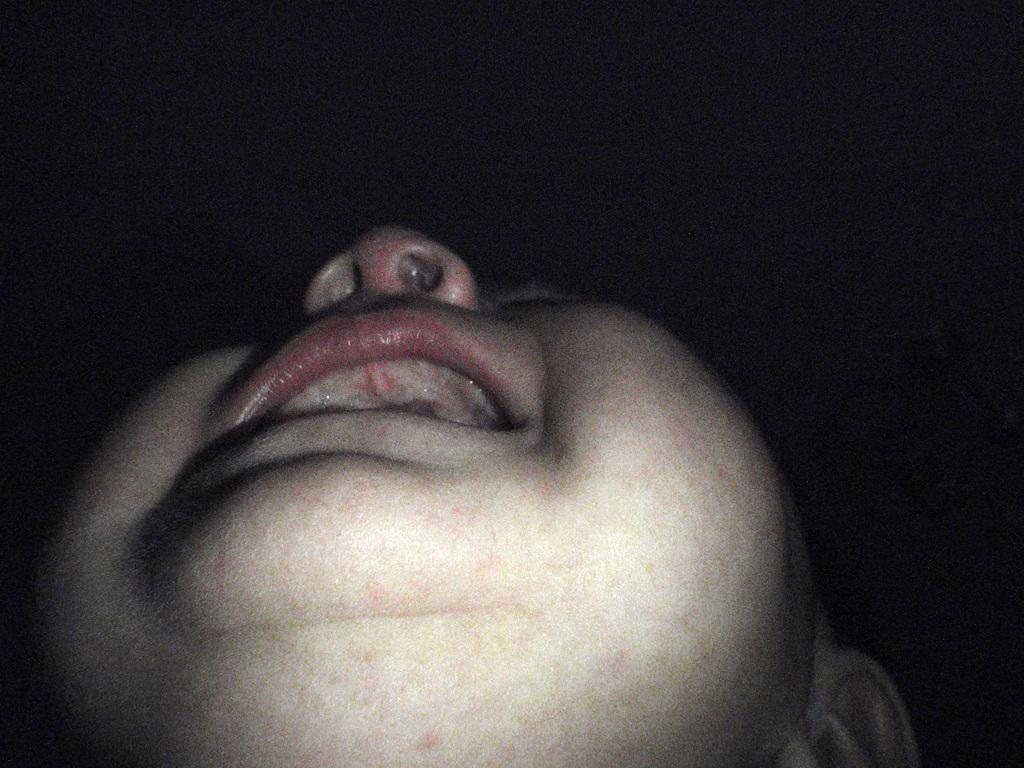What is the main subject of the image? The image appears to depict a person's face. What facial feature can be seen in the middle of the face? The nose is visible in the image. What facial feature is used for speaking and eating? The mouth is visible in the image. Which facial feature is typically used for hearing? An ear is visible in the image. How would you describe the background of the image? The background of the image is dark. What type of thread is being used to sew the person's face in the image? There is no thread or sewing activity depicted in the image; it shows a person's face with visible facial features. What part of the person's face is being cut with a knife in the image? There is no knife or cutting activity depicted in the image; it shows a person's face with visible facial features. 